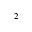Convert formula to latex. <formula><loc_0><loc_0><loc_500><loc_500>^ { 2 }</formula> 